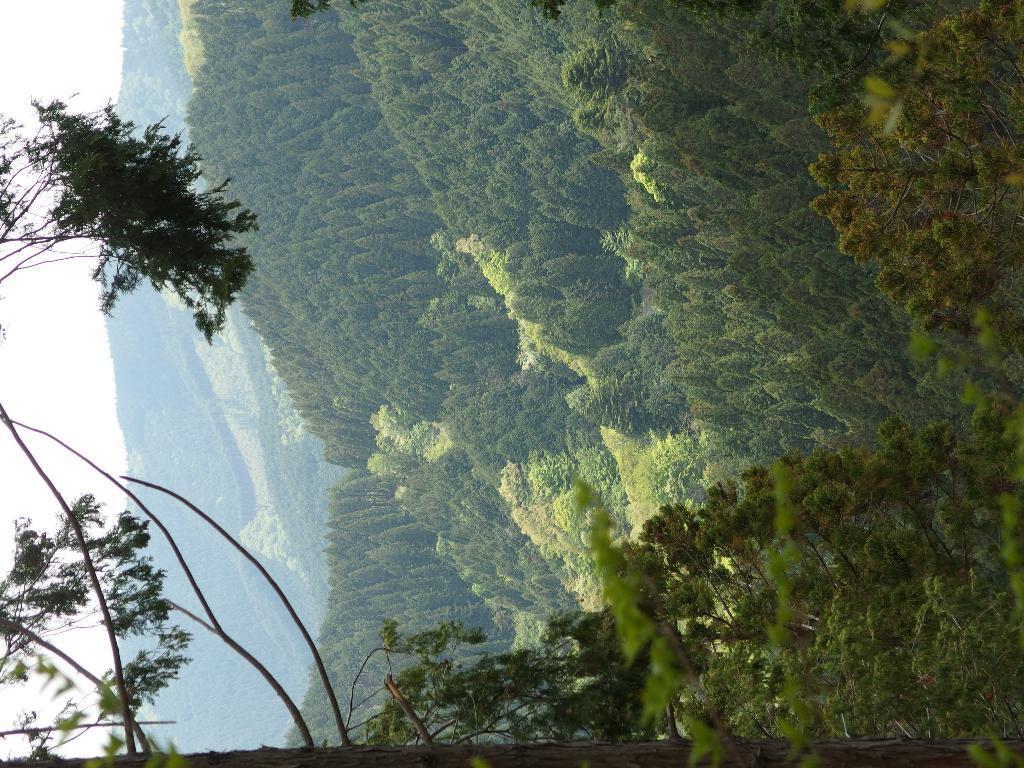Can you describe this image briefly? This is the picture of a mountain. In this image there are trees on the mountain. At the top there is sky. 